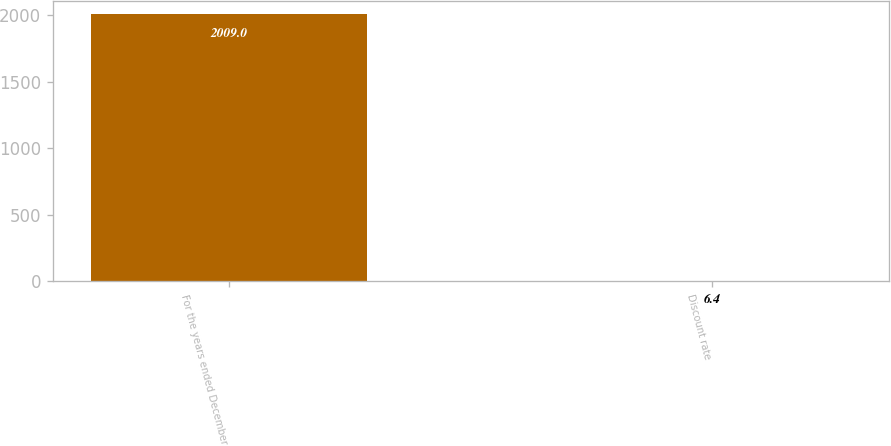Convert chart. <chart><loc_0><loc_0><loc_500><loc_500><bar_chart><fcel>For the years ended December<fcel>Discount rate<nl><fcel>2009<fcel>6.4<nl></chart> 